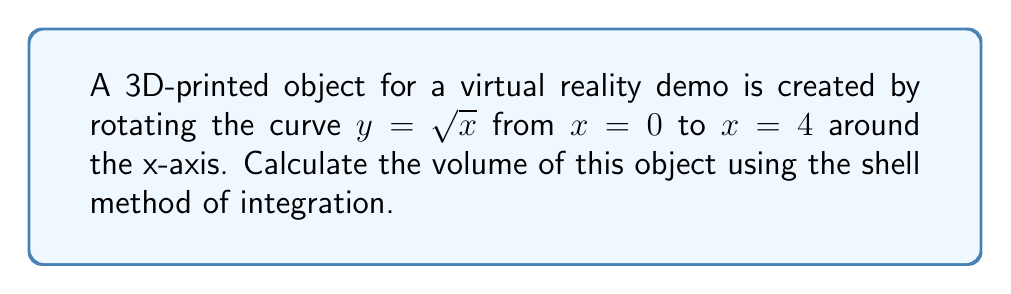Solve this math problem. To solve this problem, we'll use the shell method of integration. The steps are as follows:

1) The shell method formula for volume is:

   $$V = 2\pi \int_a^b y \cdot x \, dy$$

   where $y$ is the radius of each shell and $x$ is the height.

2) We need to express $x$ in terms of $y$. From the given equation $y = \sqrt{x}$, we can derive:

   $$x = y^2$$

3) The limits of integration will change. When $x = 0$, $y = 0$, and when $x = 4$, $y = 2$.

4) Now we can set up our integral:

   $$V = 2\pi \int_0^2 y \cdot y^2 \, dy$$

5) Simplify the integrand:

   $$V = 2\pi \int_0^2 y^3 \, dy$$

6) Integrate:

   $$V = 2\pi \left[\frac{y^4}{4}\right]_0^2$$

7) Evaluate the integral:

   $$V = 2\pi \left(\frac{2^4}{4} - \frac{0^4}{4}\right) = 2\pi \cdot 4 = 8\pi$$

Therefore, the volume of the 3D-printed object is $8\pi$ cubic units.
Answer: $8\pi$ cubic units 